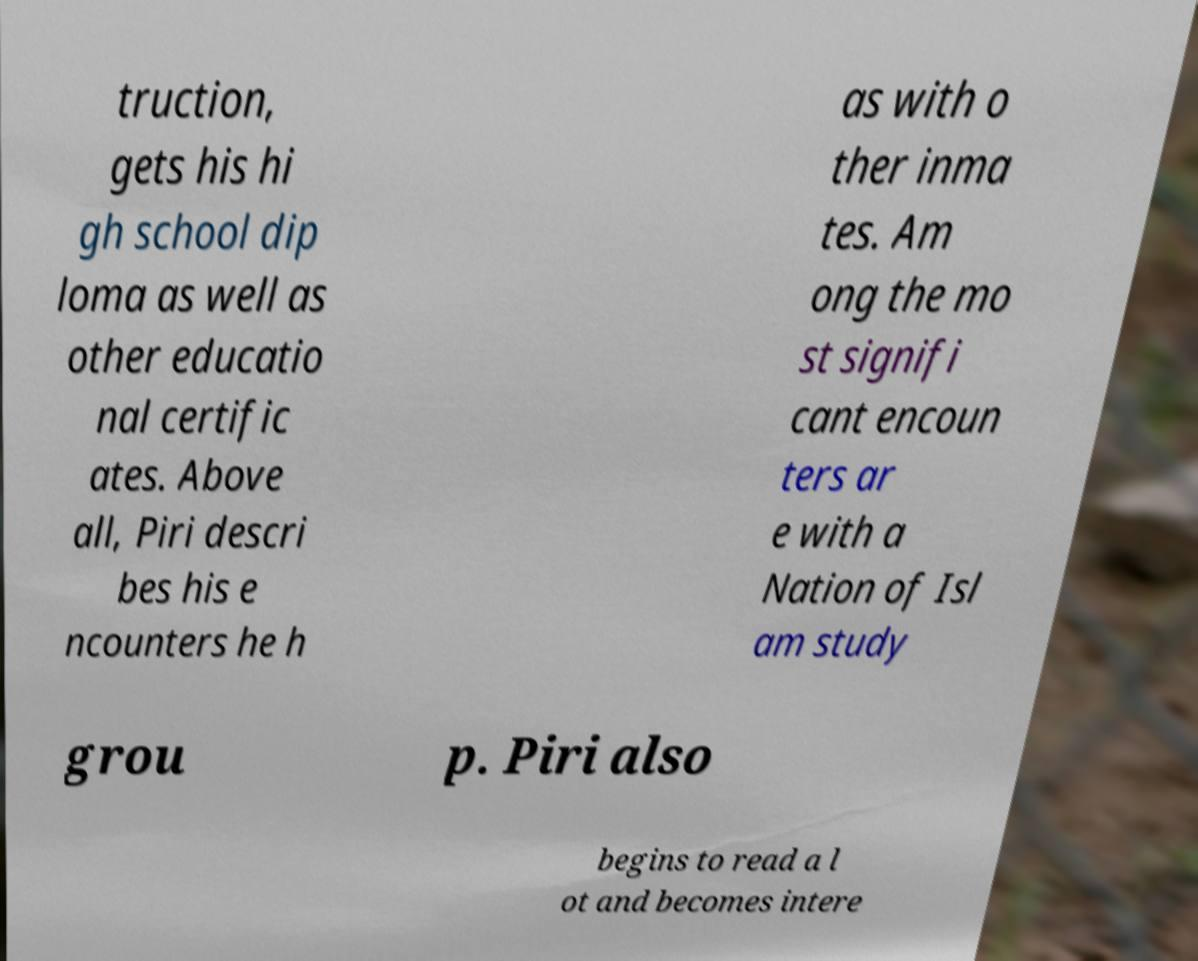Could you assist in decoding the text presented in this image and type it out clearly? truction, gets his hi gh school dip loma as well as other educatio nal certific ates. Above all, Piri descri bes his e ncounters he h as with o ther inma tes. Am ong the mo st signifi cant encoun ters ar e with a Nation of Isl am study grou p. Piri also begins to read a l ot and becomes intere 